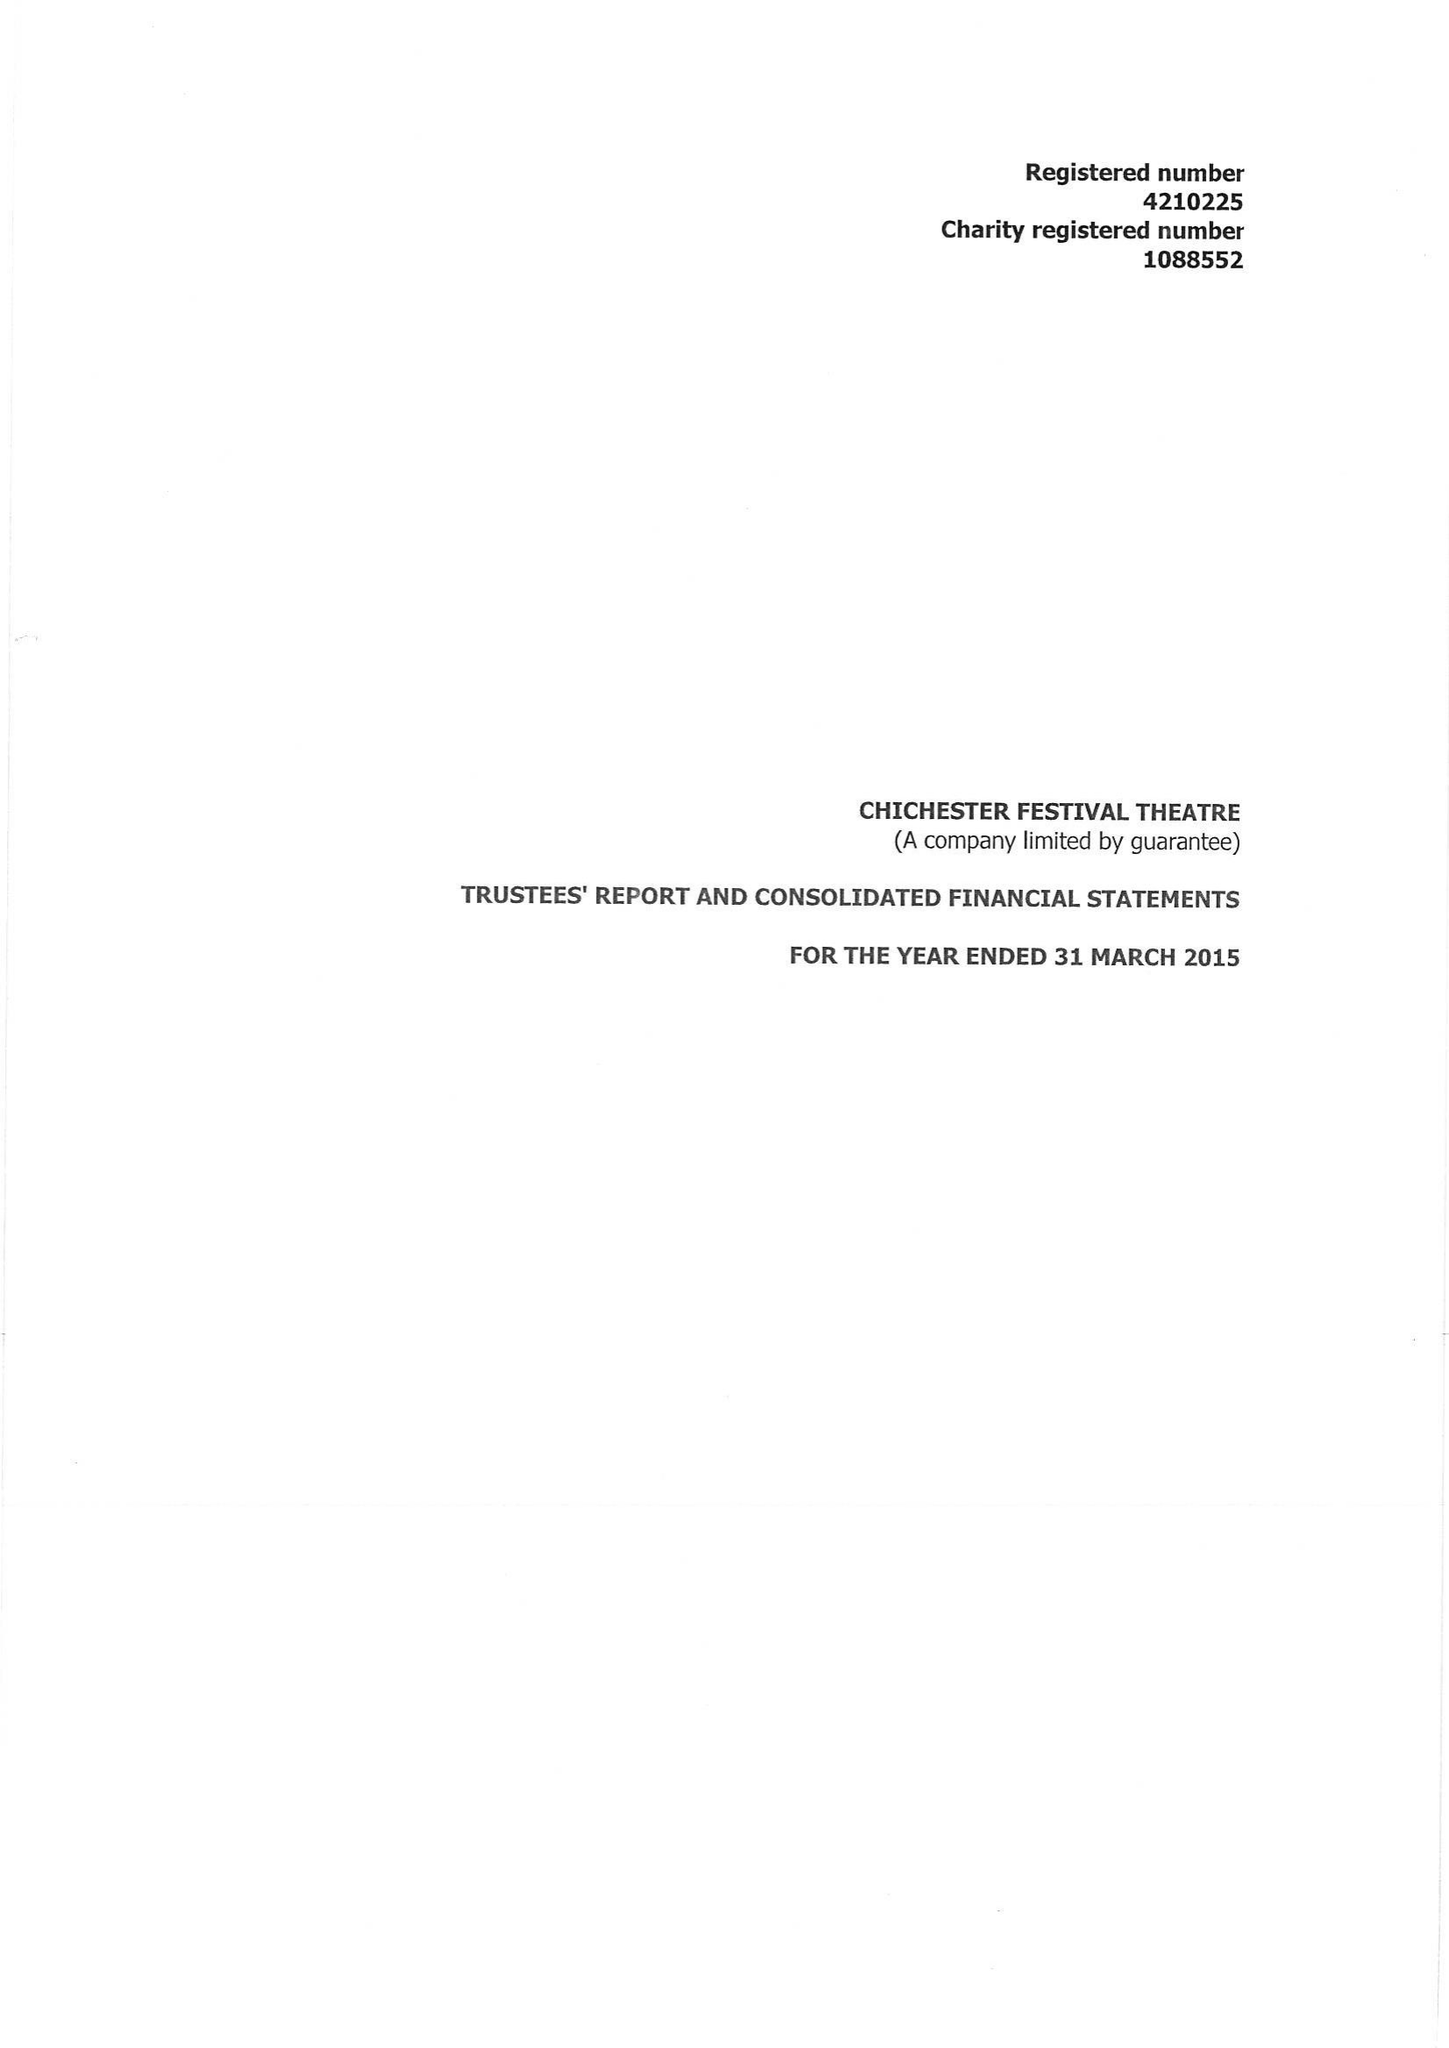What is the value for the spending_annually_in_british_pounds?
Answer the question using a single word or phrase. 13735577.00 